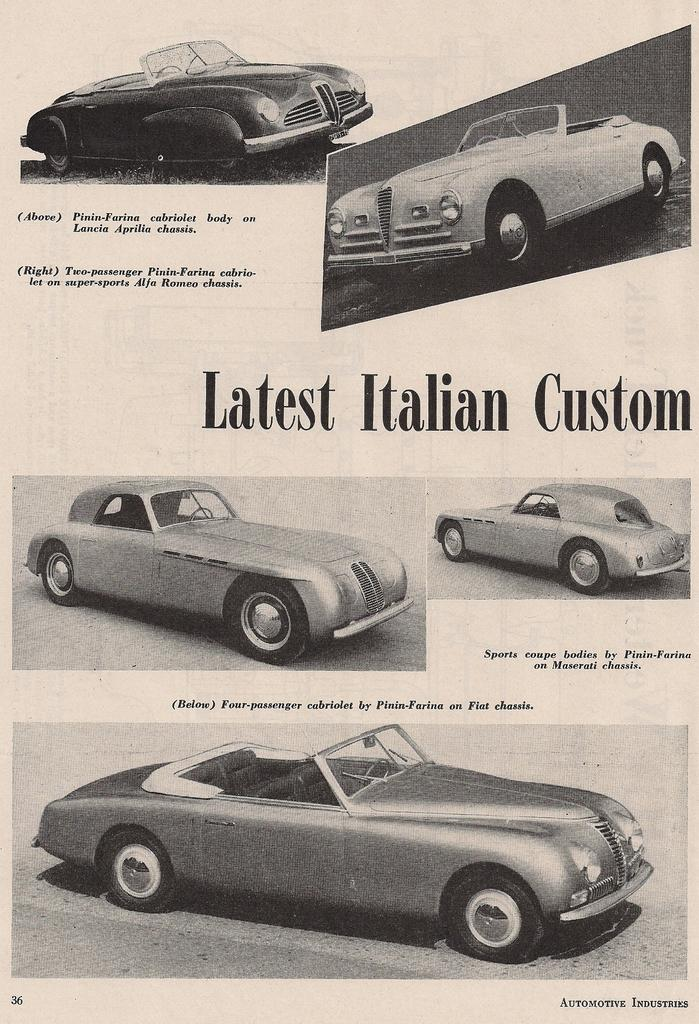What is the main object in the image? There is a paper in the image. What is depicted on the paper? There are different cars depicted on the paper. Is there any text on the paper? Yes, there is text written on the paper. How many pickles are shown on the paper in the image? There are no pickles present on the paper in the image. What type of crate is visible in the image? There is no crate present in the image. 